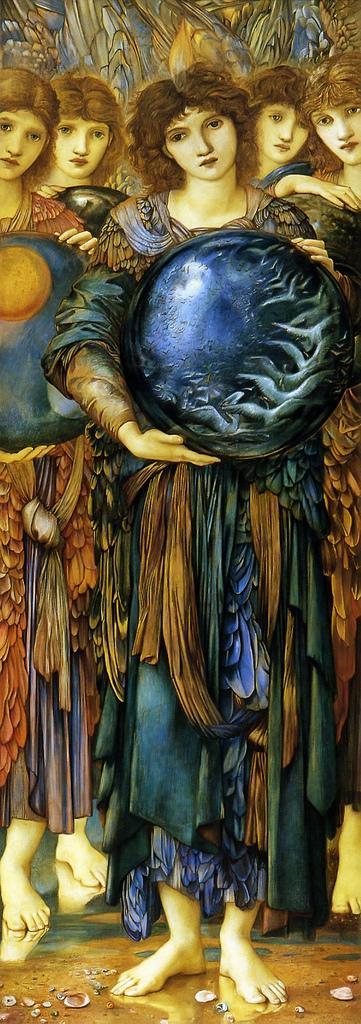Could you give a brief overview of what you see in this image? In this image there is a painting of the few people standing and holding some objects in their hands. 